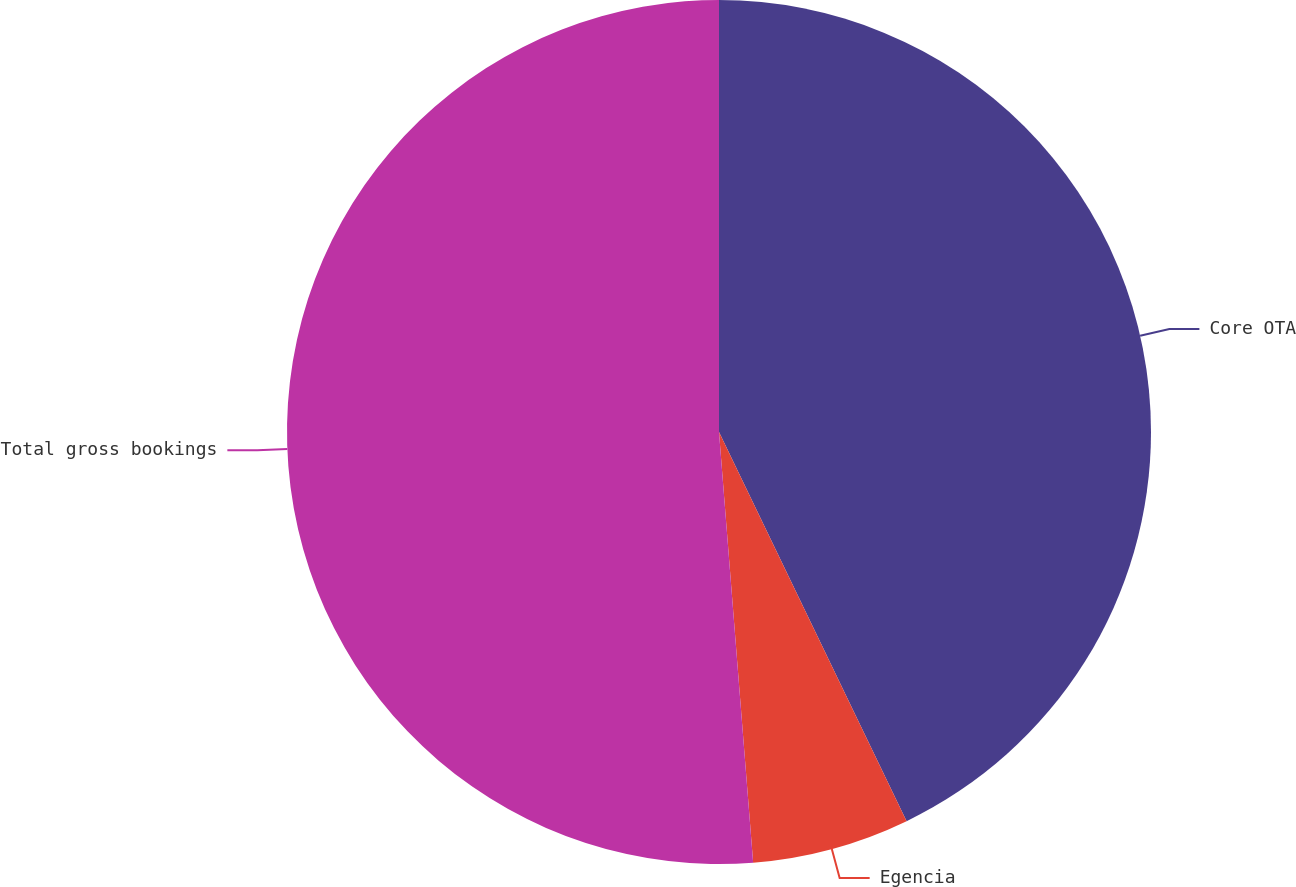Convert chart. <chart><loc_0><loc_0><loc_500><loc_500><pie_chart><fcel>Core OTA<fcel>Egencia<fcel>Total gross bookings<nl><fcel>42.85%<fcel>5.89%<fcel>51.26%<nl></chart> 